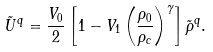Convert formula to latex. <formula><loc_0><loc_0><loc_500><loc_500>\tilde { U } ^ { q } = \frac { V _ { 0 } } { 2 } \left [ 1 - V _ { 1 } \left ( \frac { \rho _ { 0 } } { \rho _ { c } } \right ) ^ { \gamma } \right ] \tilde { \rho } ^ { q } .</formula> 